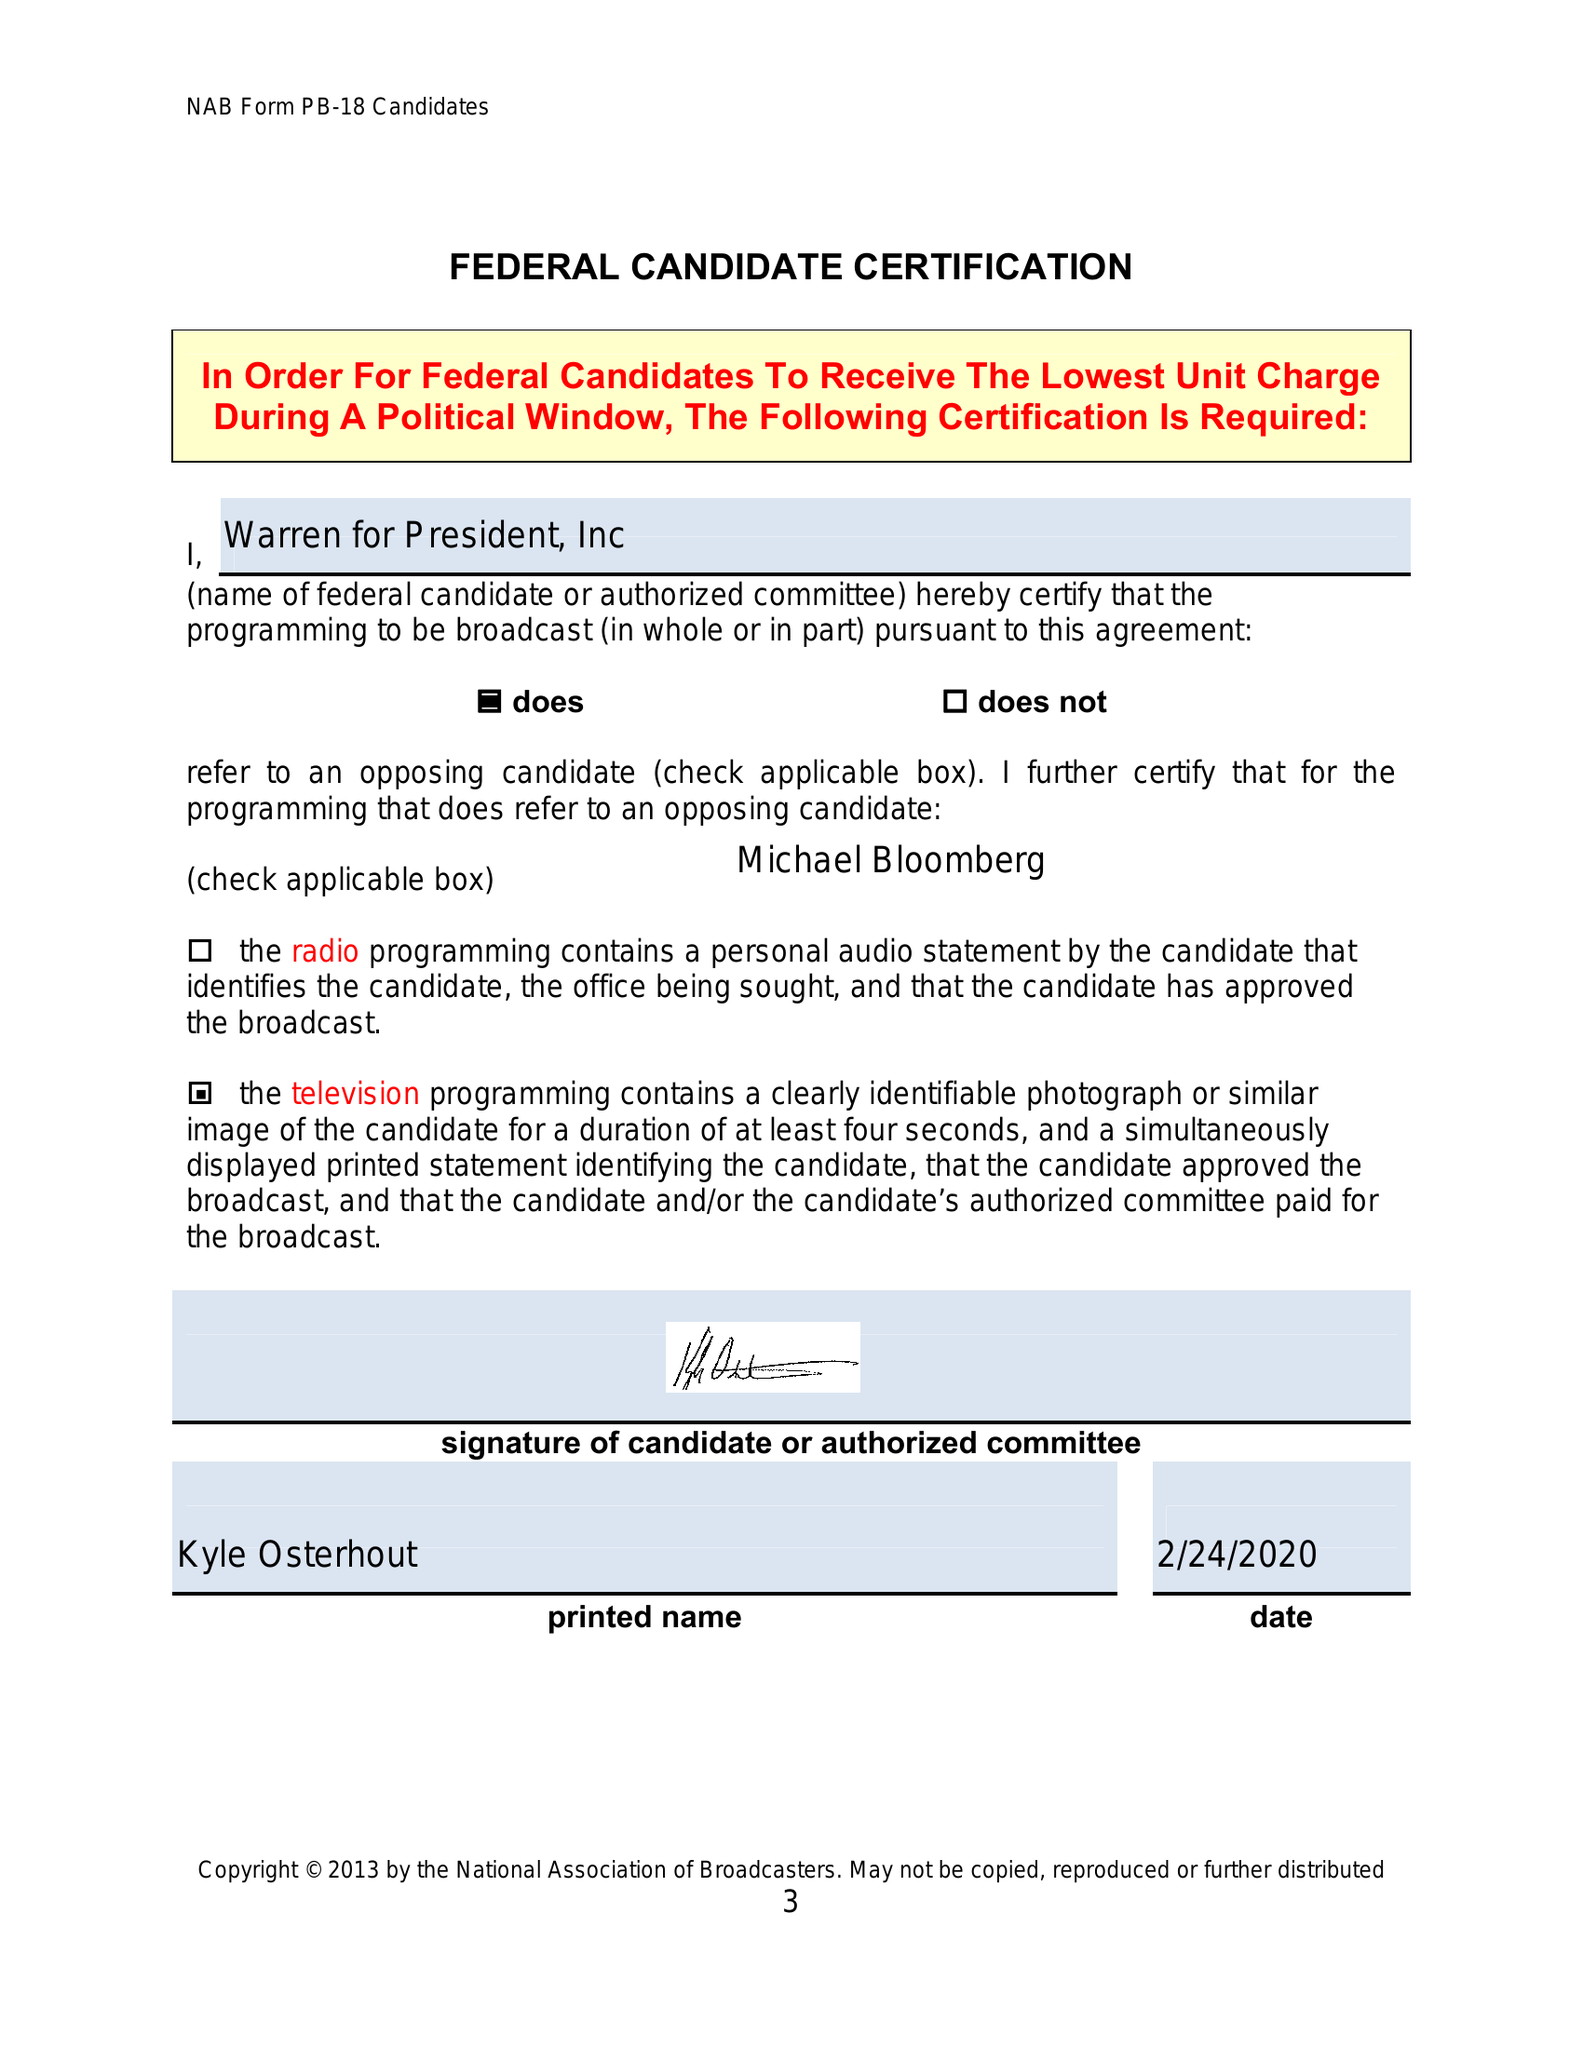What is the value for the flight_to?
Answer the question using a single word or phrase. None 